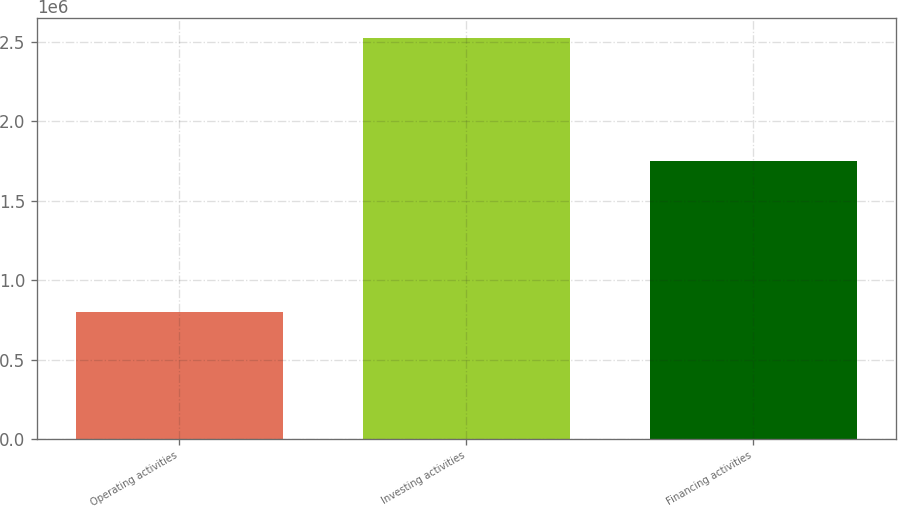<chart> <loc_0><loc_0><loc_500><loc_500><bar_chart><fcel>Operating activities<fcel>Investing activities<fcel>Financing activities<nl><fcel>799232<fcel>2.52602e+06<fcel>1.74903e+06<nl></chart> 